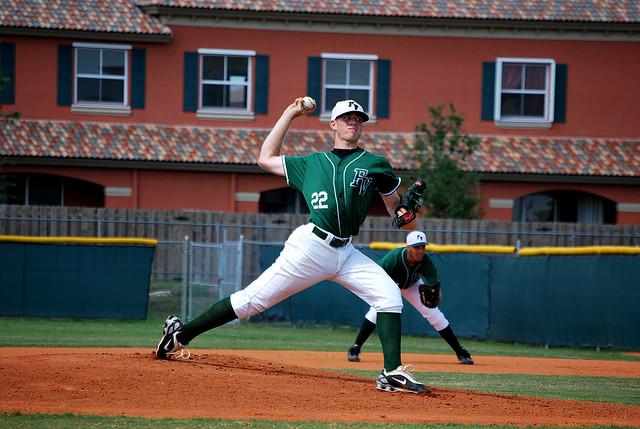What position is the man closest to the camera playing?
Write a very short answer. Pitcher. What game is being played?
Give a very brief answer. Baseball. What color socks is he wearing?
Quick response, please. Green. What ballpark are they playing in?
Answer briefly. Fenway. 